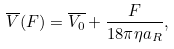Convert formula to latex. <formula><loc_0><loc_0><loc_500><loc_500>\overline { V } ( F ) = \overline { V _ { 0 } } + \frac { F } { 1 8 \pi \eta a _ { R } } ,</formula> 